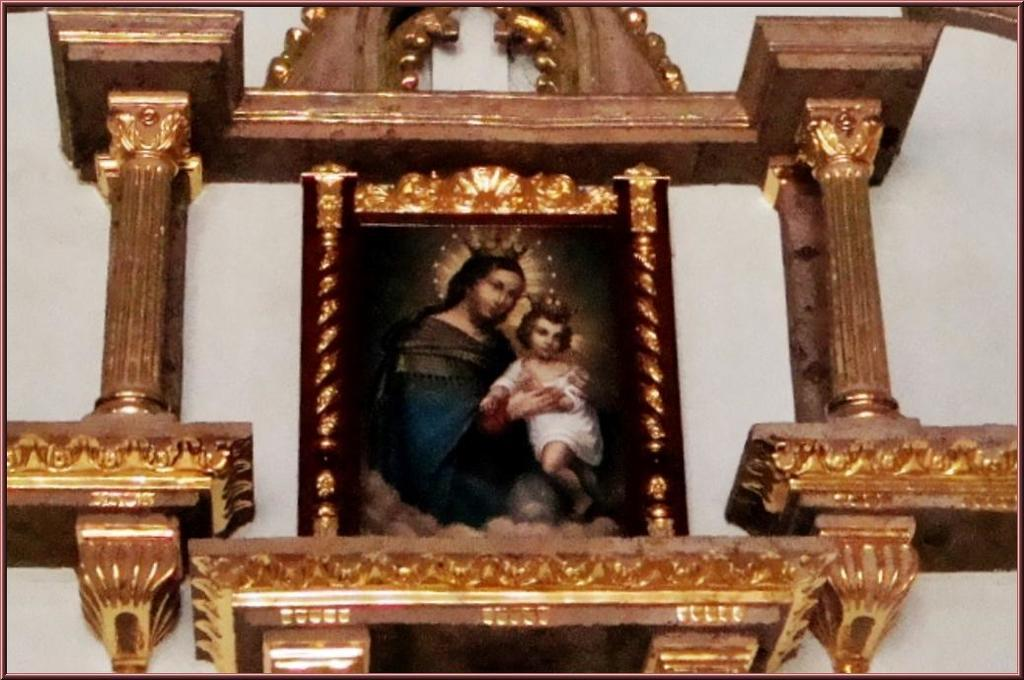What is the main object in the center of the image? There is a photo frame in the center of the image. Where is the photo frame located? The photo frame is on a wall. What can be seen in the photo inside the frame? The photo depicts a woman holding a child. What architectural features are visible in the image? There are pillars visible in the image. How many cherries are on the doll's head in the image? There is no doll or cherries present in the image. 